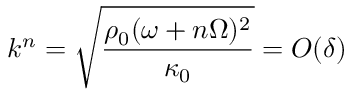<formula> <loc_0><loc_0><loc_500><loc_500>k ^ { n } = \sqrt { \frac { \rho _ { 0 } ( \omega + n \Omega ) ^ { 2 } } { \kappa _ { 0 } } } = O ( \delta )</formula> 